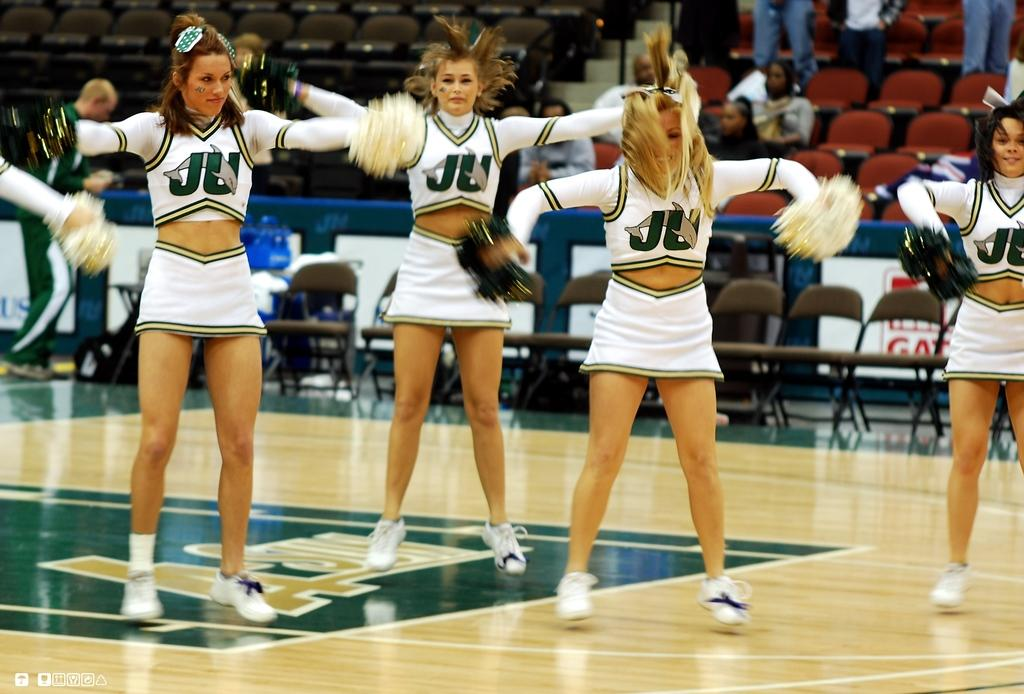Provide a one-sentence caption for the provided image. Four cheerleaders  wearing white uniforms with the letters JU on the front of their shirts. 